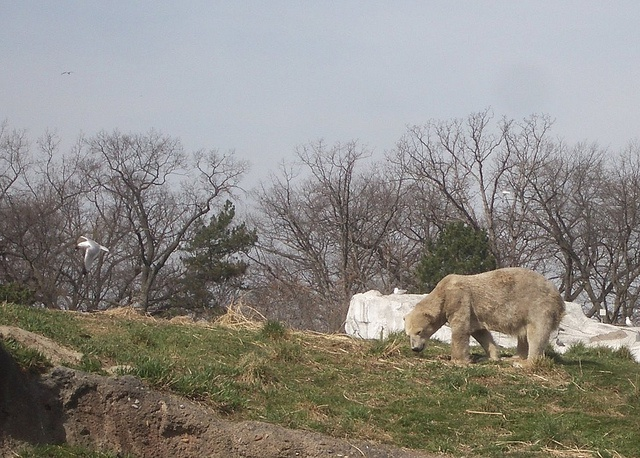Describe the objects in this image and their specific colors. I can see bear in darkgray, tan, and gray tones, bird in darkgray, gray, and lightgray tones, and bird in darkgray, lightgray, and gray tones in this image. 